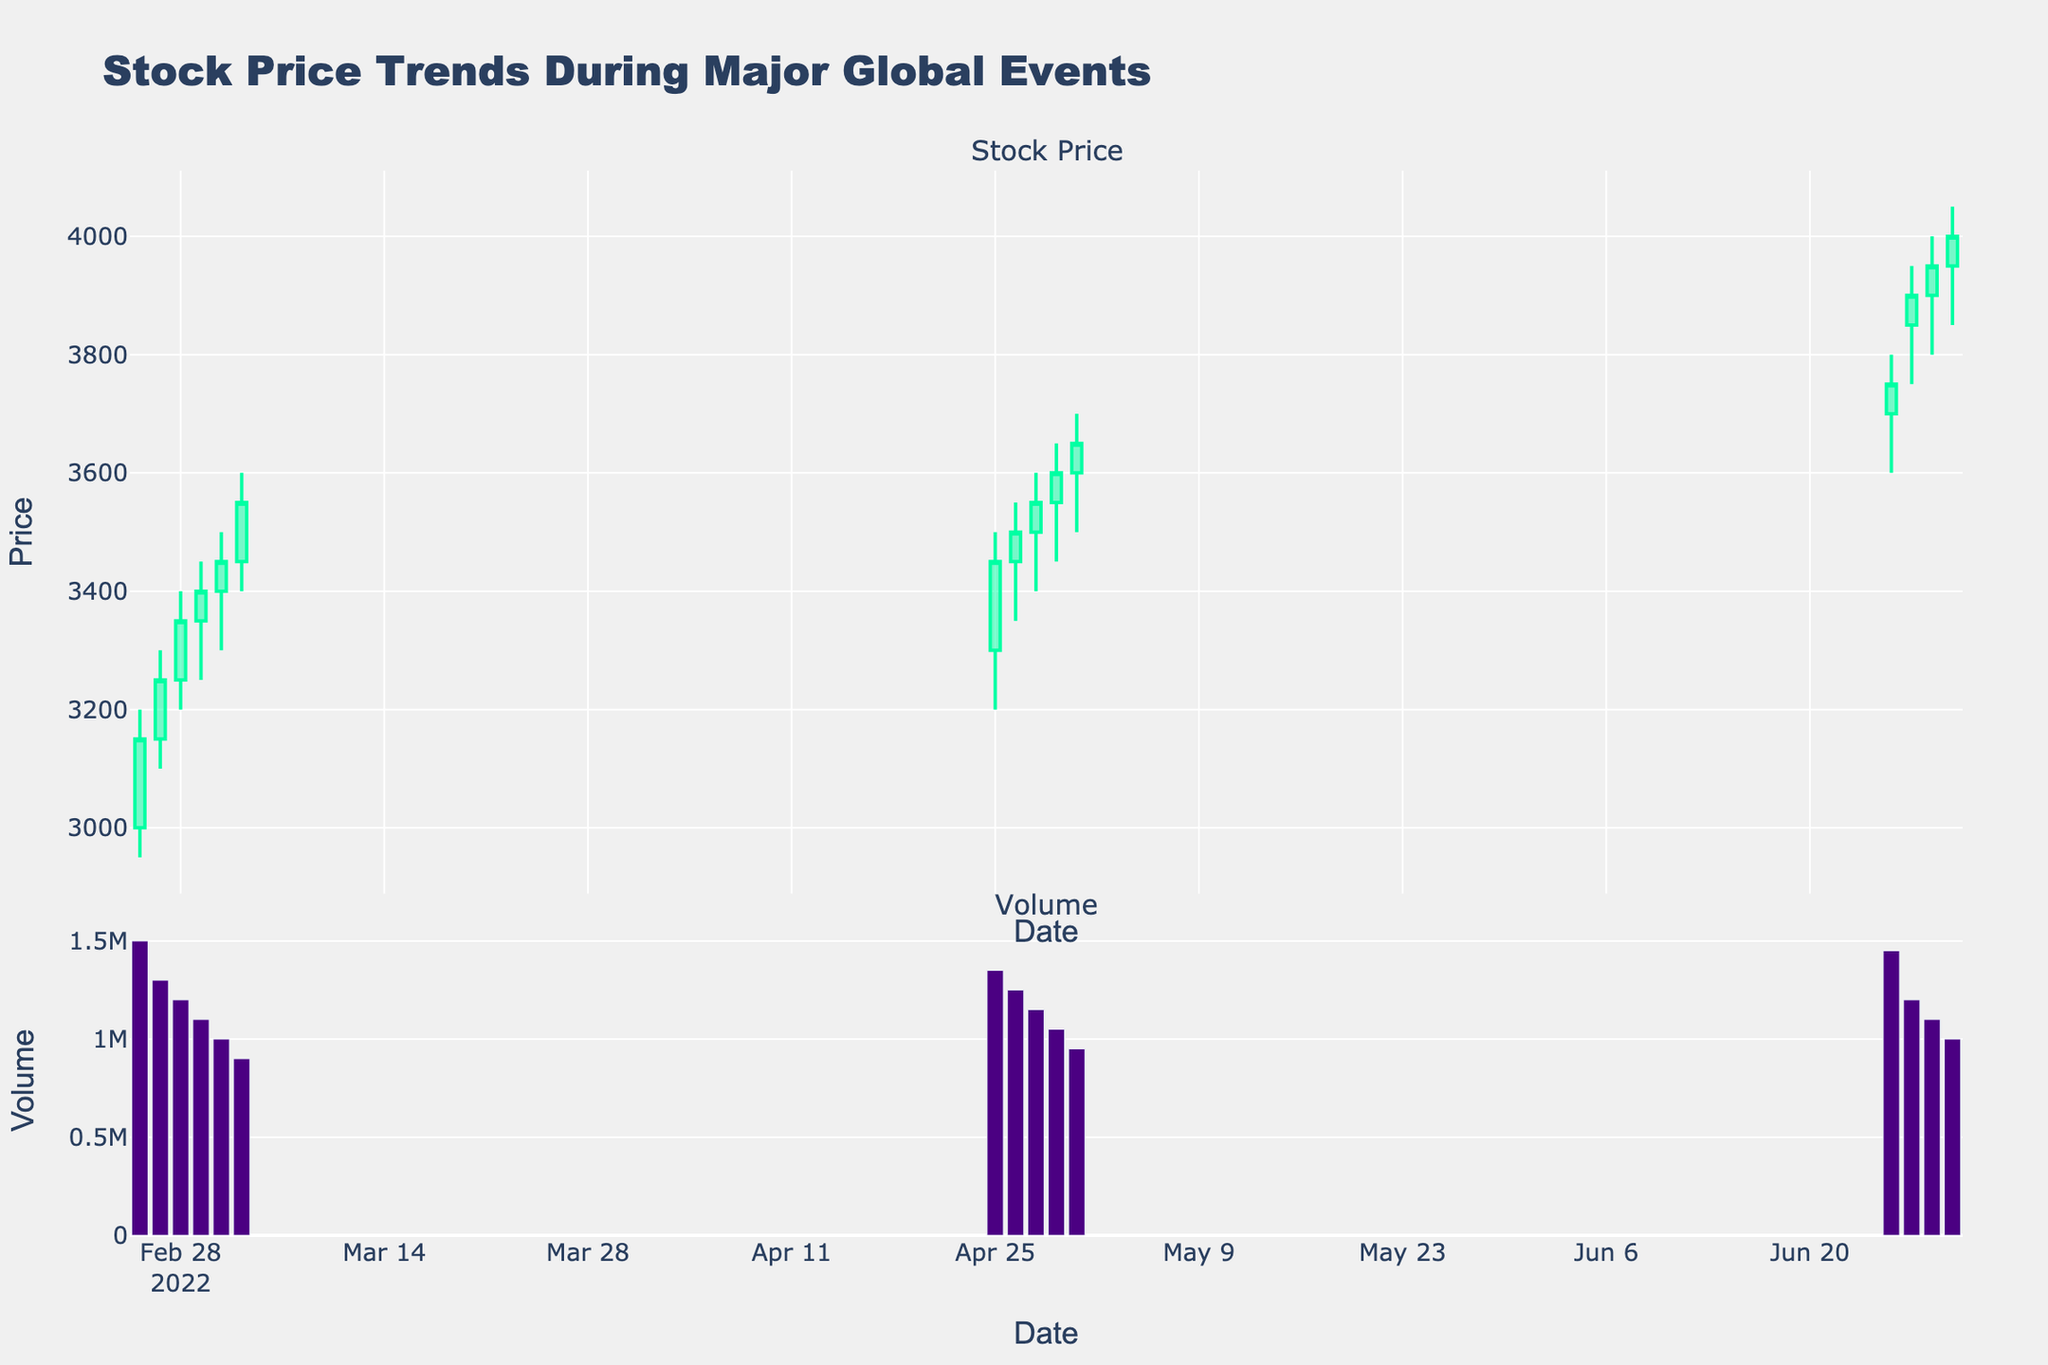What is the title of the figure? The title is displayed at the top of the figure. It reads "Stock Price Trends During Major Global Events".
Answer: Stock Price Trends During Major Global Events What are the colors used to indicate increasing and decreasing stock prices? The candlestick plot uses green for increasing stock prices and red for decreasing stock prices.
Answer: Green (increasing) and Red (decreasing) How many days are represented in total in the figure? Count the number of unique dates provided along the x-axis. There are 18 dates listed in the data.
Answer: 18 On which date was the highest trading volume observed? Look at the bar chart for volume plotted below the candlestick chart. The highest volume bar appears on 2022-06-24.
Answer: 2022-06-24 What is the average closing price of the stock in February 2022? Calculate the average closing price for the dates in February 2022. The dates in February and their closing prices are: 3150, 3250, 3350, 3400, 3450, 3550. The average is (3150 + 3250 + 3350 + 3400 + 3450 + 3550) / 6 = 3358.33
Answer: 3358.33 How does the stock price trend from February 24 to March 3, 2022? Examine the candlestick plot from February 24 to March 3. The general trend shows the stock price increasing, as the closing prices rise from 3150 to 3550.
Answer: Increasing Which month observed the highest closing stock price and what was the price? Identify the highest closing price from each month listed in the candlestick plot. 3650 in both April and June, where 3650 is the highest.
Answer: April and June, 3650 Compare the volume trends observed in February, April, and June 2022. Examine the volume bars for each of these months. February starts with high volume which gradually decreases. April shows a general downtrend in volume. June consistently has relatively high volumes.
Answer: February: decreasing, April: decreasing, June: consistent high On which date did the closing price first reach 4000 or above? Refer to the candlestick plot to find the first date when the closing price crosses 4000. The closing price first reaches 4000 on June 29.
Answer: June 29, 2022 